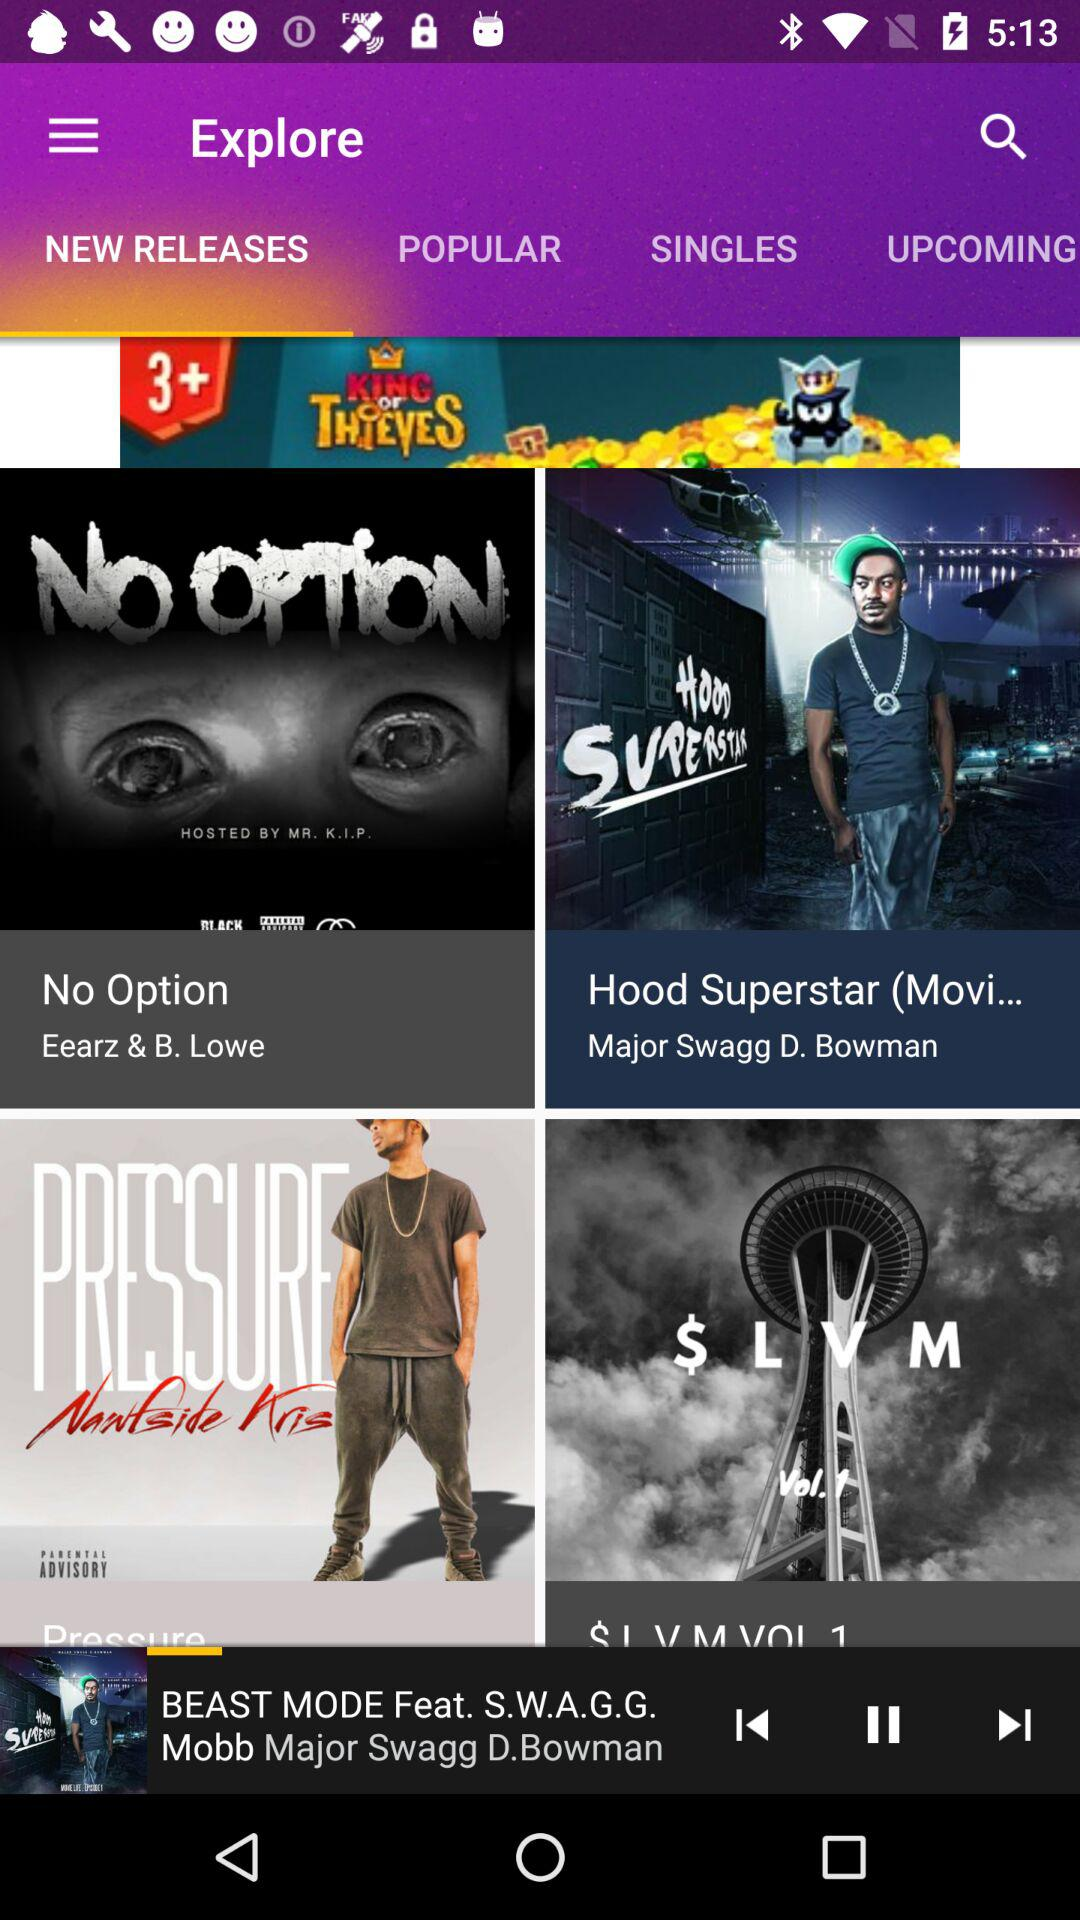How long is the song currently playing?
When the provided information is insufficient, respond with <no answer>. <no answer> 